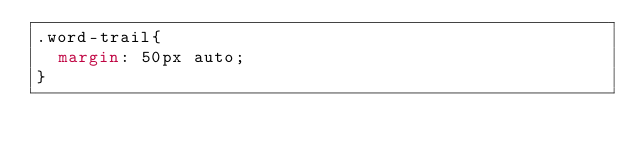<code> <loc_0><loc_0><loc_500><loc_500><_CSS_>.word-trail{
  margin: 50px auto;
}</code> 